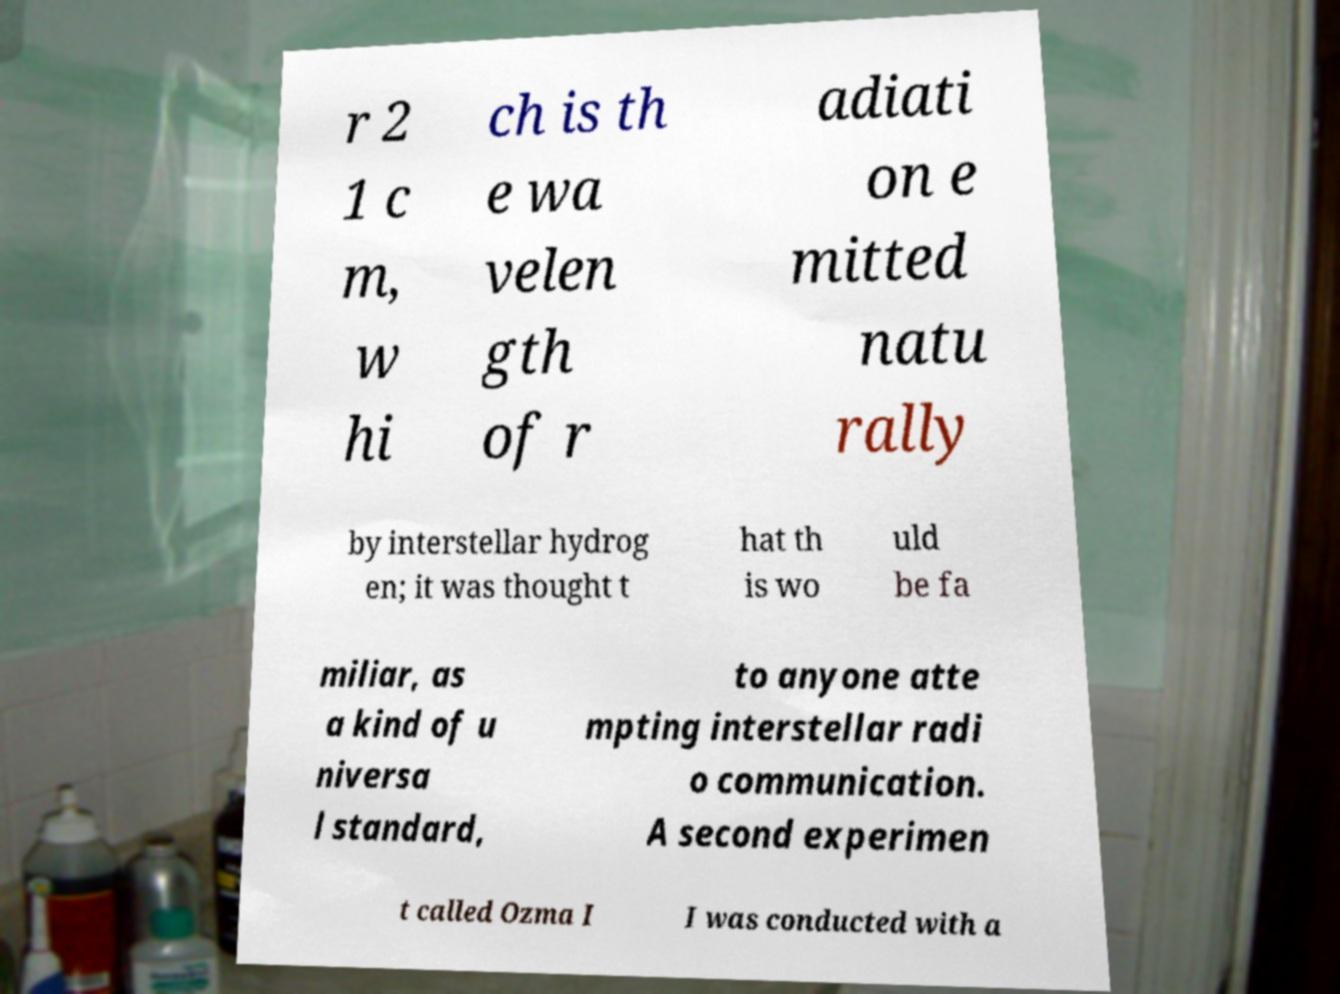Can you read and provide the text displayed in the image?This photo seems to have some interesting text. Can you extract and type it out for me? r 2 1 c m, w hi ch is th e wa velen gth of r adiati on e mitted natu rally by interstellar hydrog en; it was thought t hat th is wo uld be fa miliar, as a kind of u niversa l standard, to anyone atte mpting interstellar radi o communication. A second experimen t called Ozma I I was conducted with a 